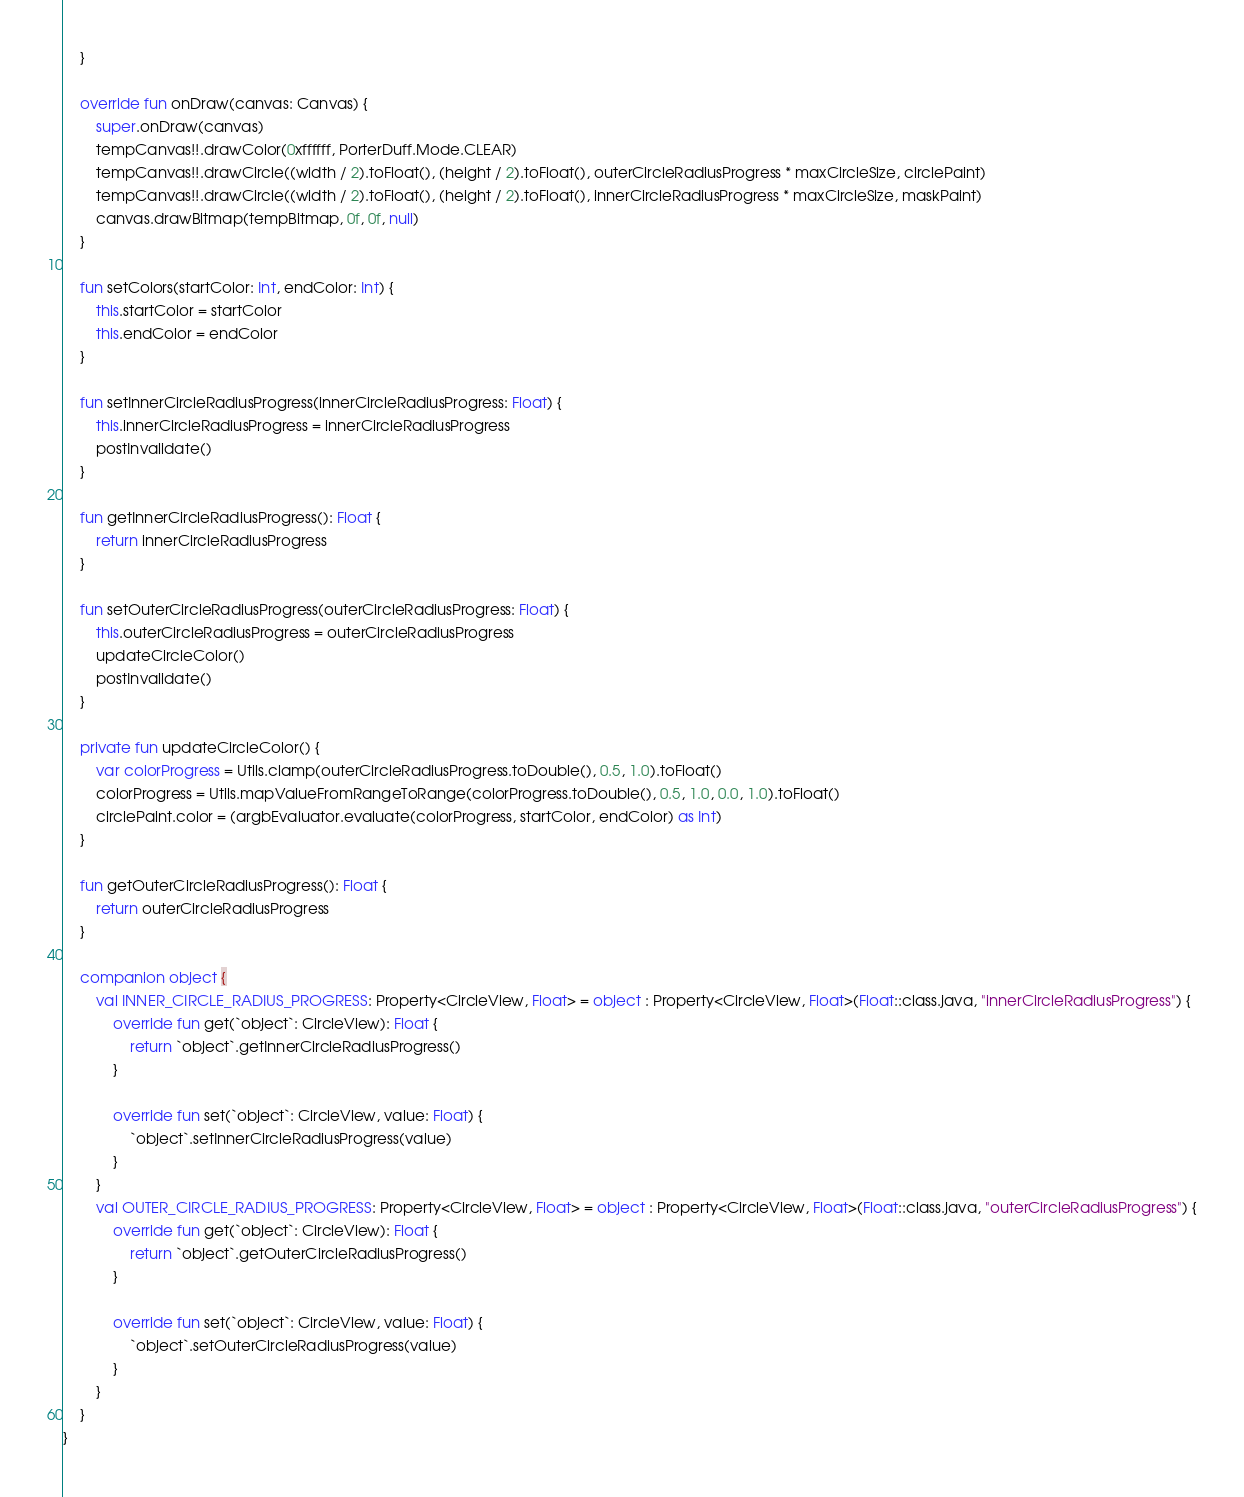<code> <loc_0><loc_0><loc_500><loc_500><_Kotlin_>    }

    override fun onDraw(canvas: Canvas) {
        super.onDraw(canvas)
        tempCanvas!!.drawColor(0xffffff, PorterDuff.Mode.CLEAR)
        tempCanvas!!.drawCircle((width / 2).toFloat(), (height / 2).toFloat(), outerCircleRadiusProgress * maxCircleSize, circlePaint)
        tempCanvas!!.drawCircle((width / 2).toFloat(), (height / 2).toFloat(), innerCircleRadiusProgress * maxCircleSize, maskPaint)
        canvas.drawBitmap(tempBitmap, 0f, 0f, null)
    }

    fun setColors(startColor: Int, endColor: Int) {
        this.startColor = startColor
        this.endColor = endColor
    }

    fun setInnerCircleRadiusProgress(innerCircleRadiusProgress: Float) {
        this.innerCircleRadiusProgress = innerCircleRadiusProgress
        postInvalidate()
    }

    fun getInnerCircleRadiusProgress(): Float {
        return innerCircleRadiusProgress
    }

    fun setOuterCircleRadiusProgress(outerCircleRadiusProgress: Float) {
        this.outerCircleRadiusProgress = outerCircleRadiusProgress
        updateCircleColor()
        postInvalidate()
    }

    private fun updateCircleColor() {
        var colorProgress = Utils.clamp(outerCircleRadiusProgress.toDouble(), 0.5, 1.0).toFloat()
        colorProgress = Utils.mapValueFromRangeToRange(colorProgress.toDouble(), 0.5, 1.0, 0.0, 1.0).toFloat()
        circlePaint.color = (argbEvaluator.evaluate(colorProgress, startColor, endColor) as Int)
    }

    fun getOuterCircleRadiusProgress(): Float {
        return outerCircleRadiusProgress
    }

    companion object {
        val INNER_CIRCLE_RADIUS_PROGRESS: Property<CircleView, Float> = object : Property<CircleView, Float>(Float::class.java, "innerCircleRadiusProgress") {
            override fun get(`object`: CircleView): Float {
                return `object`.getInnerCircleRadiusProgress()
            }

            override fun set(`object`: CircleView, value: Float) {
                `object`.setInnerCircleRadiusProgress(value)
            }
        }
        val OUTER_CIRCLE_RADIUS_PROGRESS: Property<CircleView, Float> = object : Property<CircleView, Float>(Float::class.java, "outerCircleRadiusProgress") {
            override fun get(`object`: CircleView): Float {
                return `object`.getOuterCircleRadiusProgress()
            }

            override fun set(`object`: CircleView, value: Float) {
                `object`.setOuterCircleRadiusProgress(value)
            }
        }
    }
}</code> 